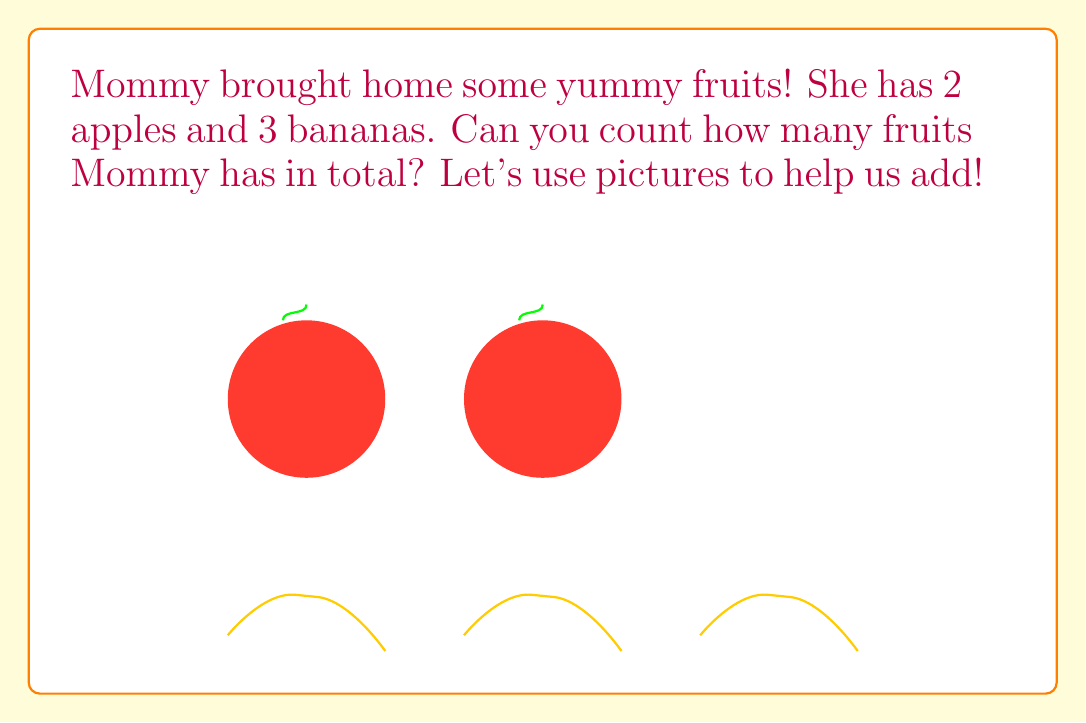Show me your answer to this math problem. Let's count the fruits together!

1. First, we'll count the apples:
   - We can see 2 red round apples in the picture.
   - So, we have $2$ apples.

2. Now, let's count the bananas:
   - We can see 3 yellow curved bananas in the picture.
   - So, we have $3$ bananas.

3. To find the total number of fruits, we need to add the apples and bananas:
   - We can use our fingers to help us!
   - Hold up 2 fingers for the apples.
   - Now, add 3 more fingers for the bananas.
   - Count all your fingers: 1, 2, 3, 4, 5

So, $2$ apples plus $3$ bananas gives us $5$ fruits in total!

We can write this as an addition problem:
$$ 2 + 3 = 5 $$
Answer: 5 fruits 